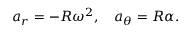<formula> <loc_0><loc_0><loc_500><loc_500>a _ { r } = - R \omega ^ { 2 } , \quad a _ { \theta } = R \alpha .</formula> 